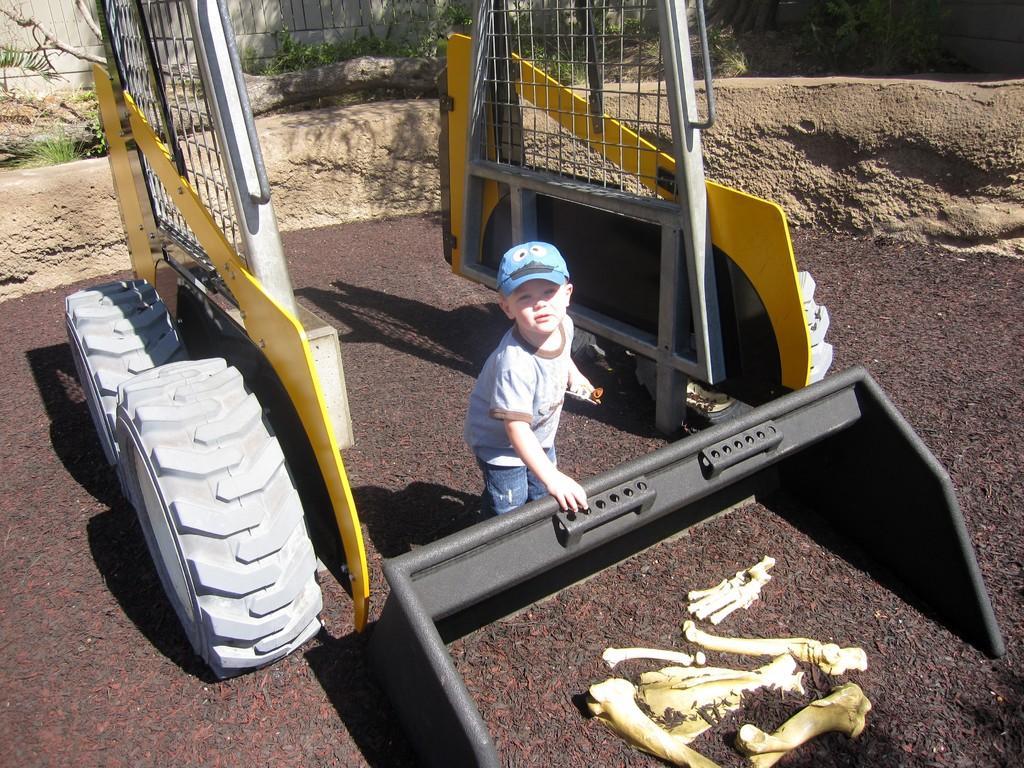Please provide a concise description of this image. In this image I can see in the middle a little boy is standing, he wore t-shirt, trouser, cap and it is in the shape of a JCB a plastic thing, at the bottom it looks like bones. 